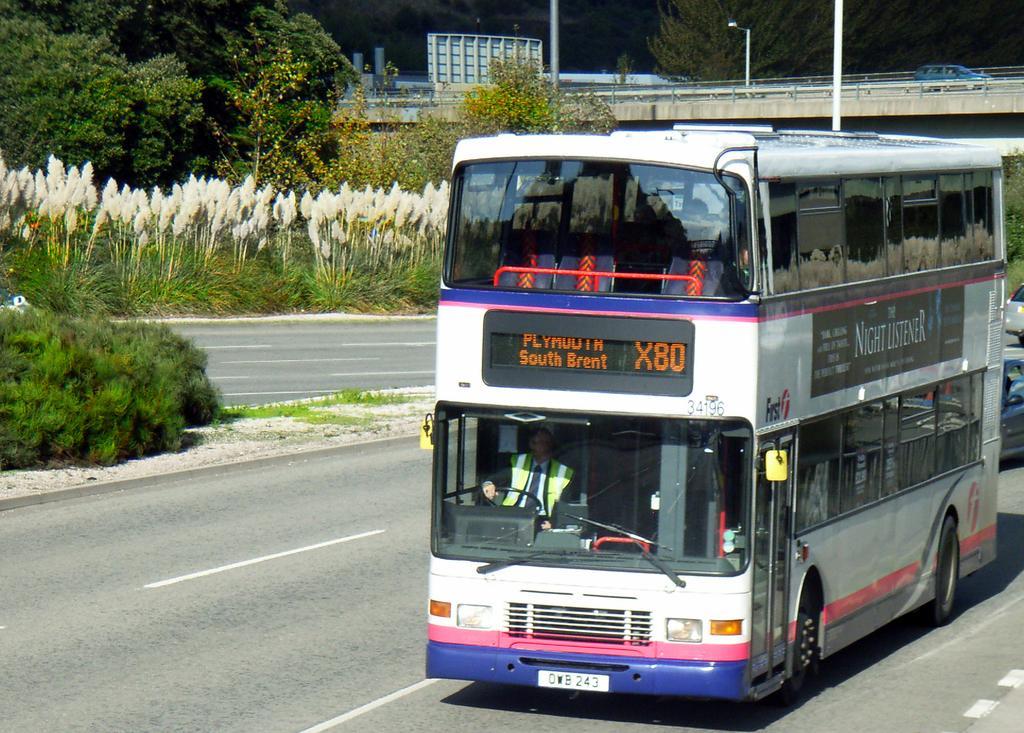Can you describe this image briefly? In this image we can see a bus and some vehicles on the road. We can also see some people inside a bus. We can also see a car on a fly over, some poles, plants, grass, a board with some poles, a street pole and a group of trees. 